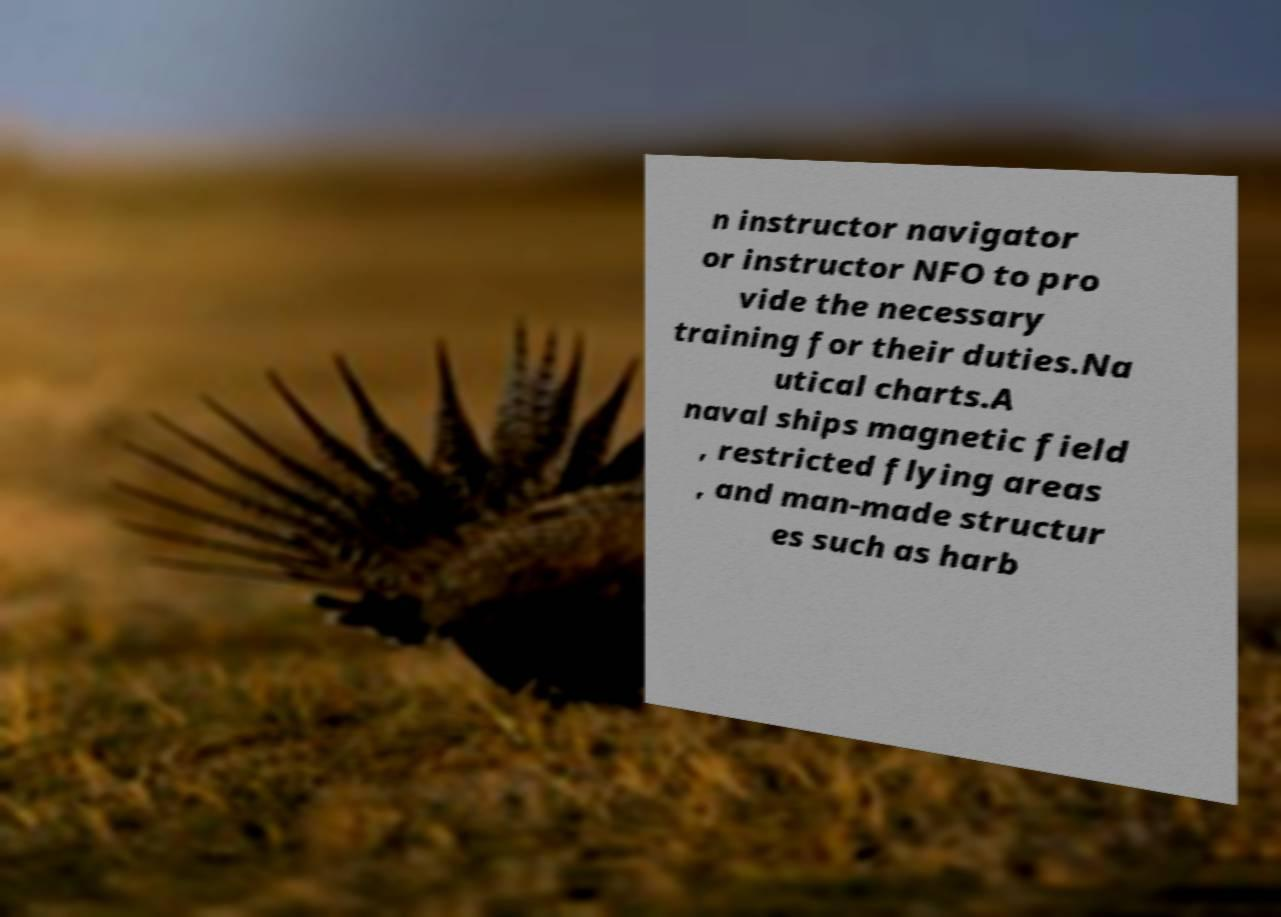Can you read and provide the text displayed in the image?This photo seems to have some interesting text. Can you extract and type it out for me? n instructor navigator or instructor NFO to pro vide the necessary training for their duties.Na utical charts.A naval ships magnetic field , restricted flying areas , and man-made structur es such as harb 